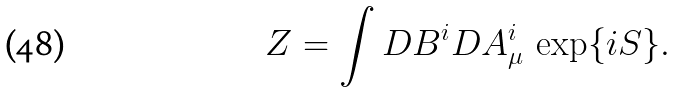<formula> <loc_0><loc_0><loc_500><loc_500>Z = \int D B ^ { i } D A _ { \mu } ^ { i } \, \exp \{ i S \} .</formula> 